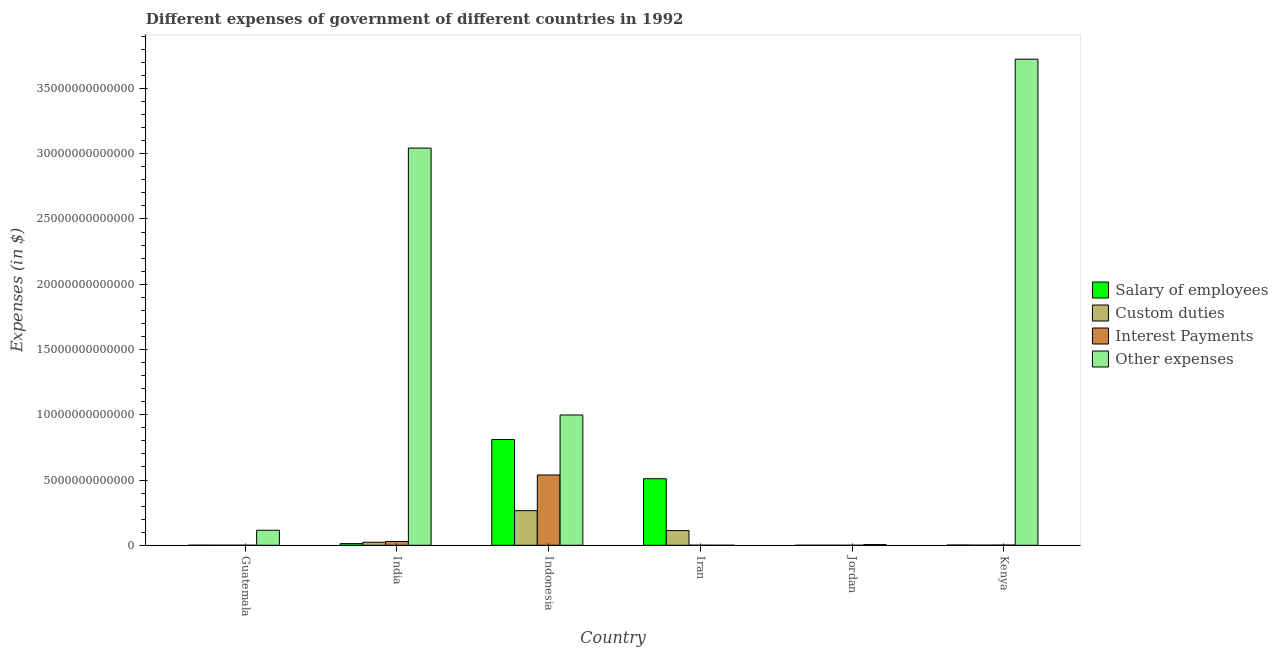Are the number of bars per tick equal to the number of legend labels?
Your answer should be very brief. Yes. How many bars are there on the 6th tick from the left?
Offer a very short reply. 4. What is the label of the 6th group of bars from the left?
Offer a terse response. Kenya. What is the amount spent on custom duties in Guatemala?
Keep it short and to the point. 1.15e+09. Across all countries, what is the maximum amount spent on custom duties?
Provide a succinct answer. 2.65e+12. Across all countries, what is the minimum amount spent on salary of employees?
Your response must be concise. 5.57e+08. In which country was the amount spent on other expenses maximum?
Your answer should be very brief. Kenya. In which country was the amount spent on salary of employees minimum?
Your answer should be very brief. Jordan. What is the total amount spent on salary of employees in the graph?
Give a very brief answer. 1.34e+13. What is the difference between the amount spent on salary of employees in India and that in Kenya?
Ensure brevity in your answer.  1.07e+11. What is the difference between the amount spent on interest payments in Iran and the amount spent on salary of employees in Jordan?
Keep it short and to the point. 2.44e+09. What is the average amount spent on salary of employees per country?
Your response must be concise. 2.23e+12. What is the difference between the amount spent on salary of employees and amount spent on other expenses in India?
Provide a succinct answer. -3.03e+13. In how many countries, is the amount spent on other expenses greater than 1000000000000 $?
Provide a short and direct response. 4. What is the ratio of the amount spent on custom duties in India to that in Kenya?
Provide a short and direct response. 30.07. Is the amount spent on custom duties in Indonesia less than that in Iran?
Provide a short and direct response. No. What is the difference between the highest and the second highest amount spent on interest payments?
Give a very brief answer. 5.10e+12. What is the difference between the highest and the lowest amount spent on custom duties?
Offer a terse response. 2.65e+12. Is the sum of the amount spent on salary of employees in India and Indonesia greater than the maximum amount spent on other expenses across all countries?
Your answer should be compact. No. Is it the case that in every country, the sum of the amount spent on interest payments and amount spent on other expenses is greater than the sum of amount spent on custom duties and amount spent on salary of employees?
Give a very brief answer. No. What does the 3rd bar from the left in Iran represents?
Keep it short and to the point. Interest Payments. What does the 2nd bar from the right in Indonesia represents?
Make the answer very short. Interest Payments. How many bars are there?
Provide a short and direct response. 24. Are all the bars in the graph horizontal?
Keep it short and to the point. No. What is the difference between two consecutive major ticks on the Y-axis?
Your response must be concise. 5.00e+12. Does the graph contain any zero values?
Provide a succinct answer. No. Does the graph contain grids?
Provide a short and direct response. No. Where does the legend appear in the graph?
Provide a short and direct response. Center right. How are the legend labels stacked?
Offer a very short reply. Vertical. What is the title of the graph?
Your answer should be very brief. Different expenses of government of different countries in 1992. What is the label or title of the X-axis?
Offer a very short reply. Country. What is the label or title of the Y-axis?
Provide a short and direct response. Expenses (in $). What is the Expenses (in $) of Salary of employees in Guatemala?
Your answer should be very brief. 1.87e+09. What is the Expenses (in $) in Custom duties in Guatemala?
Ensure brevity in your answer.  1.15e+09. What is the Expenses (in $) in Interest Payments in Guatemala?
Make the answer very short. 5.30e+08. What is the Expenses (in $) in Other expenses in Guatemala?
Make the answer very short. 1.15e+12. What is the Expenses (in $) of Salary of employees in India?
Make the answer very short. 1.26e+11. What is the Expenses (in $) of Custom duties in India?
Provide a short and direct response. 2.33e+11. What is the Expenses (in $) of Interest Payments in India?
Keep it short and to the point. 2.91e+11. What is the Expenses (in $) in Other expenses in India?
Your answer should be compact. 3.04e+13. What is the Expenses (in $) of Salary of employees in Indonesia?
Provide a succinct answer. 8.10e+12. What is the Expenses (in $) of Custom duties in Indonesia?
Offer a very short reply. 2.65e+12. What is the Expenses (in $) of Interest Payments in Indonesia?
Provide a succinct answer. 5.39e+12. What is the Expenses (in $) of Other expenses in Indonesia?
Keep it short and to the point. 9.98e+12. What is the Expenses (in $) of Salary of employees in Iran?
Your answer should be very brief. 5.10e+12. What is the Expenses (in $) of Custom duties in Iran?
Provide a short and direct response. 1.12e+12. What is the Expenses (in $) of Interest Payments in Iran?
Offer a very short reply. 3.00e+09. What is the Expenses (in $) in Other expenses in Iran?
Your answer should be compact. 8.91e+08. What is the Expenses (in $) in Salary of employees in Jordan?
Your answer should be compact. 5.57e+08. What is the Expenses (in $) of Custom duties in Jordan?
Offer a terse response. 3.89e+08. What is the Expenses (in $) of Interest Payments in Jordan?
Provide a succinct answer. 1.56e+08. What is the Expenses (in $) of Other expenses in Jordan?
Give a very brief answer. 5.39e+1. What is the Expenses (in $) of Salary of employees in Kenya?
Your answer should be very brief. 1.91e+1. What is the Expenses (in $) of Custom duties in Kenya?
Your response must be concise. 7.74e+09. What is the Expenses (in $) of Interest Payments in Kenya?
Give a very brief answer. 1.49e+1. What is the Expenses (in $) in Other expenses in Kenya?
Your answer should be very brief. 3.72e+13. Across all countries, what is the maximum Expenses (in $) of Salary of employees?
Offer a terse response. 8.10e+12. Across all countries, what is the maximum Expenses (in $) of Custom duties?
Your answer should be compact. 2.65e+12. Across all countries, what is the maximum Expenses (in $) of Interest Payments?
Make the answer very short. 5.39e+12. Across all countries, what is the maximum Expenses (in $) of Other expenses?
Make the answer very short. 3.72e+13. Across all countries, what is the minimum Expenses (in $) in Salary of employees?
Keep it short and to the point. 5.57e+08. Across all countries, what is the minimum Expenses (in $) in Custom duties?
Make the answer very short. 3.89e+08. Across all countries, what is the minimum Expenses (in $) of Interest Payments?
Make the answer very short. 1.56e+08. Across all countries, what is the minimum Expenses (in $) in Other expenses?
Your answer should be very brief. 8.91e+08. What is the total Expenses (in $) of Salary of employees in the graph?
Give a very brief answer. 1.34e+13. What is the total Expenses (in $) in Custom duties in the graph?
Your answer should be very brief. 4.02e+12. What is the total Expenses (in $) of Interest Payments in the graph?
Keep it short and to the point. 5.69e+12. What is the total Expenses (in $) in Other expenses in the graph?
Your response must be concise. 7.89e+13. What is the difference between the Expenses (in $) in Salary of employees in Guatemala and that in India?
Your answer should be compact. -1.24e+11. What is the difference between the Expenses (in $) in Custom duties in Guatemala and that in India?
Keep it short and to the point. -2.32e+11. What is the difference between the Expenses (in $) of Interest Payments in Guatemala and that in India?
Give a very brief answer. -2.90e+11. What is the difference between the Expenses (in $) of Other expenses in Guatemala and that in India?
Provide a succinct answer. -2.93e+13. What is the difference between the Expenses (in $) in Salary of employees in Guatemala and that in Indonesia?
Your answer should be compact. -8.10e+12. What is the difference between the Expenses (in $) of Custom duties in Guatemala and that in Indonesia?
Your answer should be very brief. -2.65e+12. What is the difference between the Expenses (in $) in Interest Payments in Guatemala and that in Indonesia?
Your answer should be very brief. -5.39e+12. What is the difference between the Expenses (in $) of Other expenses in Guatemala and that in Indonesia?
Offer a terse response. -8.83e+12. What is the difference between the Expenses (in $) in Salary of employees in Guatemala and that in Iran?
Your answer should be very brief. -5.10e+12. What is the difference between the Expenses (in $) of Custom duties in Guatemala and that in Iran?
Your response must be concise. -1.12e+12. What is the difference between the Expenses (in $) in Interest Payments in Guatemala and that in Iran?
Offer a terse response. -2.47e+09. What is the difference between the Expenses (in $) in Other expenses in Guatemala and that in Iran?
Give a very brief answer. 1.15e+12. What is the difference between the Expenses (in $) of Salary of employees in Guatemala and that in Jordan?
Provide a short and direct response. 1.32e+09. What is the difference between the Expenses (in $) in Custom duties in Guatemala and that in Jordan?
Give a very brief answer. 7.58e+08. What is the difference between the Expenses (in $) in Interest Payments in Guatemala and that in Jordan?
Provide a short and direct response. 3.74e+08. What is the difference between the Expenses (in $) of Other expenses in Guatemala and that in Jordan?
Offer a very short reply. 1.10e+12. What is the difference between the Expenses (in $) of Salary of employees in Guatemala and that in Kenya?
Your response must be concise. -1.72e+1. What is the difference between the Expenses (in $) of Custom duties in Guatemala and that in Kenya?
Your response must be concise. -6.59e+09. What is the difference between the Expenses (in $) of Interest Payments in Guatemala and that in Kenya?
Ensure brevity in your answer.  -1.44e+1. What is the difference between the Expenses (in $) in Other expenses in Guatemala and that in Kenya?
Ensure brevity in your answer.  -3.61e+13. What is the difference between the Expenses (in $) in Salary of employees in India and that in Indonesia?
Ensure brevity in your answer.  -7.98e+12. What is the difference between the Expenses (in $) in Custom duties in India and that in Indonesia?
Offer a terse response. -2.42e+12. What is the difference between the Expenses (in $) of Interest Payments in India and that in Indonesia?
Provide a short and direct response. -5.10e+12. What is the difference between the Expenses (in $) of Other expenses in India and that in Indonesia?
Your response must be concise. 2.04e+13. What is the difference between the Expenses (in $) in Salary of employees in India and that in Iran?
Your answer should be very brief. -4.97e+12. What is the difference between the Expenses (in $) in Custom duties in India and that in Iran?
Provide a short and direct response. -8.92e+11. What is the difference between the Expenses (in $) of Interest Payments in India and that in Iran?
Offer a very short reply. 2.88e+11. What is the difference between the Expenses (in $) in Other expenses in India and that in Iran?
Ensure brevity in your answer.  3.04e+13. What is the difference between the Expenses (in $) of Salary of employees in India and that in Jordan?
Your answer should be very brief. 1.26e+11. What is the difference between the Expenses (in $) of Custom duties in India and that in Jordan?
Your answer should be very brief. 2.32e+11. What is the difference between the Expenses (in $) in Interest Payments in India and that in Jordan?
Offer a terse response. 2.90e+11. What is the difference between the Expenses (in $) in Other expenses in India and that in Jordan?
Make the answer very short. 3.04e+13. What is the difference between the Expenses (in $) in Salary of employees in India and that in Kenya?
Provide a short and direct response. 1.07e+11. What is the difference between the Expenses (in $) of Custom duties in India and that in Kenya?
Your answer should be compact. 2.25e+11. What is the difference between the Expenses (in $) in Interest Payments in India and that in Kenya?
Provide a short and direct response. 2.76e+11. What is the difference between the Expenses (in $) in Other expenses in India and that in Kenya?
Provide a succinct answer. -6.81e+12. What is the difference between the Expenses (in $) in Salary of employees in Indonesia and that in Iran?
Your response must be concise. 3.00e+12. What is the difference between the Expenses (in $) in Custom duties in Indonesia and that in Iran?
Your answer should be very brief. 1.53e+12. What is the difference between the Expenses (in $) of Interest Payments in Indonesia and that in Iran?
Make the answer very short. 5.38e+12. What is the difference between the Expenses (in $) in Other expenses in Indonesia and that in Iran?
Your response must be concise. 9.98e+12. What is the difference between the Expenses (in $) of Salary of employees in Indonesia and that in Jordan?
Ensure brevity in your answer.  8.10e+12. What is the difference between the Expenses (in $) in Custom duties in Indonesia and that in Jordan?
Your answer should be very brief. 2.65e+12. What is the difference between the Expenses (in $) of Interest Payments in Indonesia and that in Jordan?
Keep it short and to the point. 5.39e+12. What is the difference between the Expenses (in $) of Other expenses in Indonesia and that in Jordan?
Provide a succinct answer. 9.93e+12. What is the difference between the Expenses (in $) of Salary of employees in Indonesia and that in Kenya?
Keep it short and to the point. 8.09e+12. What is the difference between the Expenses (in $) in Custom duties in Indonesia and that in Kenya?
Your answer should be compact. 2.64e+12. What is the difference between the Expenses (in $) of Interest Payments in Indonesia and that in Kenya?
Your answer should be very brief. 5.37e+12. What is the difference between the Expenses (in $) of Other expenses in Indonesia and that in Kenya?
Your response must be concise. -2.73e+13. What is the difference between the Expenses (in $) of Salary of employees in Iran and that in Jordan?
Offer a very short reply. 5.10e+12. What is the difference between the Expenses (in $) of Custom duties in Iran and that in Jordan?
Make the answer very short. 1.12e+12. What is the difference between the Expenses (in $) of Interest Payments in Iran and that in Jordan?
Offer a very short reply. 2.84e+09. What is the difference between the Expenses (in $) in Other expenses in Iran and that in Jordan?
Provide a short and direct response. -5.30e+1. What is the difference between the Expenses (in $) of Salary of employees in Iran and that in Kenya?
Offer a very short reply. 5.08e+12. What is the difference between the Expenses (in $) in Custom duties in Iran and that in Kenya?
Offer a terse response. 1.12e+12. What is the difference between the Expenses (in $) of Interest Payments in Iran and that in Kenya?
Offer a very short reply. -1.19e+1. What is the difference between the Expenses (in $) of Other expenses in Iran and that in Kenya?
Offer a very short reply. -3.72e+13. What is the difference between the Expenses (in $) in Salary of employees in Jordan and that in Kenya?
Your answer should be compact. -1.86e+1. What is the difference between the Expenses (in $) of Custom duties in Jordan and that in Kenya?
Your response must be concise. -7.35e+09. What is the difference between the Expenses (in $) of Interest Payments in Jordan and that in Kenya?
Make the answer very short. -1.48e+1. What is the difference between the Expenses (in $) of Other expenses in Jordan and that in Kenya?
Make the answer very short. -3.72e+13. What is the difference between the Expenses (in $) of Salary of employees in Guatemala and the Expenses (in $) of Custom duties in India?
Provide a short and direct response. -2.31e+11. What is the difference between the Expenses (in $) in Salary of employees in Guatemala and the Expenses (in $) in Interest Payments in India?
Ensure brevity in your answer.  -2.89e+11. What is the difference between the Expenses (in $) of Salary of employees in Guatemala and the Expenses (in $) of Other expenses in India?
Ensure brevity in your answer.  -3.04e+13. What is the difference between the Expenses (in $) of Custom duties in Guatemala and the Expenses (in $) of Interest Payments in India?
Provide a short and direct response. -2.89e+11. What is the difference between the Expenses (in $) of Custom duties in Guatemala and the Expenses (in $) of Other expenses in India?
Your answer should be compact. -3.04e+13. What is the difference between the Expenses (in $) of Interest Payments in Guatemala and the Expenses (in $) of Other expenses in India?
Your answer should be very brief. -3.04e+13. What is the difference between the Expenses (in $) of Salary of employees in Guatemala and the Expenses (in $) of Custom duties in Indonesia?
Give a very brief answer. -2.65e+12. What is the difference between the Expenses (in $) of Salary of employees in Guatemala and the Expenses (in $) of Interest Payments in Indonesia?
Offer a terse response. -5.38e+12. What is the difference between the Expenses (in $) of Salary of employees in Guatemala and the Expenses (in $) of Other expenses in Indonesia?
Ensure brevity in your answer.  -9.98e+12. What is the difference between the Expenses (in $) of Custom duties in Guatemala and the Expenses (in $) of Interest Payments in Indonesia?
Give a very brief answer. -5.38e+12. What is the difference between the Expenses (in $) of Custom duties in Guatemala and the Expenses (in $) of Other expenses in Indonesia?
Offer a very short reply. -9.98e+12. What is the difference between the Expenses (in $) of Interest Payments in Guatemala and the Expenses (in $) of Other expenses in Indonesia?
Ensure brevity in your answer.  -9.98e+12. What is the difference between the Expenses (in $) of Salary of employees in Guatemala and the Expenses (in $) of Custom duties in Iran?
Offer a terse response. -1.12e+12. What is the difference between the Expenses (in $) of Salary of employees in Guatemala and the Expenses (in $) of Interest Payments in Iran?
Keep it short and to the point. -1.13e+09. What is the difference between the Expenses (in $) in Salary of employees in Guatemala and the Expenses (in $) in Other expenses in Iran?
Ensure brevity in your answer.  9.83e+08. What is the difference between the Expenses (in $) in Custom duties in Guatemala and the Expenses (in $) in Interest Payments in Iran?
Offer a terse response. -1.85e+09. What is the difference between the Expenses (in $) of Custom duties in Guatemala and the Expenses (in $) of Other expenses in Iran?
Ensure brevity in your answer.  2.56e+08. What is the difference between the Expenses (in $) of Interest Payments in Guatemala and the Expenses (in $) of Other expenses in Iran?
Your answer should be compact. -3.61e+08. What is the difference between the Expenses (in $) in Salary of employees in Guatemala and the Expenses (in $) in Custom duties in Jordan?
Keep it short and to the point. 1.49e+09. What is the difference between the Expenses (in $) of Salary of employees in Guatemala and the Expenses (in $) of Interest Payments in Jordan?
Make the answer very short. 1.72e+09. What is the difference between the Expenses (in $) of Salary of employees in Guatemala and the Expenses (in $) of Other expenses in Jordan?
Offer a very short reply. -5.20e+1. What is the difference between the Expenses (in $) of Custom duties in Guatemala and the Expenses (in $) of Interest Payments in Jordan?
Your answer should be very brief. 9.92e+08. What is the difference between the Expenses (in $) in Custom duties in Guatemala and the Expenses (in $) in Other expenses in Jordan?
Offer a very short reply. -5.28e+1. What is the difference between the Expenses (in $) in Interest Payments in Guatemala and the Expenses (in $) in Other expenses in Jordan?
Offer a terse response. -5.34e+1. What is the difference between the Expenses (in $) in Salary of employees in Guatemala and the Expenses (in $) in Custom duties in Kenya?
Your answer should be very brief. -5.86e+09. What is the difference between the Expenses (in $) of Salary of employees in Guatemala and the Expenses (in $) of Interest Payments in Kenya?
Ensure brevity in your answer.  -1.30e+1. What is the difference between the Expenses (in $) in Salary of employees in Guatemala and the Expenses (in $) in Other expenses in Kenya?
Provide a short and direct response. -3.72e+13. What is the difference between the Expenses (in $) in Custom duties in Guatemala and the Expenses (in $) in Interest Payments in Kenya?
Provide a succinct answer. -1.38e+1. What is the difference between the Expenses (in $) in Custom duties in Guatemala and the Expenses (in $) in Other expenses in Kenya?
Offer a very short reply. -3.72e+13. What is the difference between the Expenses (in $) in Interest Payments in Guatemala and the Expenses (in $) in Other expenses in Kenya?
Your response must be concise. -3.72e+13. What is the difference between the Expenses (in $) of Salary of employees in India and the Expenses (in $) of Custom duties in Indonesia?
Provide a short and direct response. -2.53e+12. What is the difference between the Expenses (in $) in Salary of employees in India and the Expenses (in $) in Interest Payments in Indonesia?
Provide a succinct answer. -5.26e+12. What is the difference between the Expenses (in $) of Salary of employees in India and the Expenses (in $) of Other expenses in Indonesia?
Keep it short and to the point. -9.86e+12. What is the difference between the Expenses (in $) in Custom duties in India and the Expenses (in $) in Interest Payments in Indonesia?
Offer a terse response. -5.15e+12. What is the difference between the Expenses (in $) in Custom duties in India and the Expenses (in $) in Other expenses in Indonesia?
Provide a succinct answer. -9.75e+12. What is the difference between the Expenses (in $) of Interest Payments in India and the Expenses (in $) of Other expenses in Indonesia?
Offer a very short reply. -9.69e+12. What is the difference between the Expenses (in $) in Salary of employees in India and the Expenses (in $) in Custom duties in Iran?
Ensure brevity in your answer.  -9.98e+11. What is the difference between the Expenses (in $) in Salary of employees in India and the Expenses (in $) in Interest Payments in Iran?
Provide a succinct answer. 1.23e+11. What is the difference between the Expenses (in $) of Salary of employees in India and the Expenses (in $) of Other expenses in Iran?
Provide a short and direct response. 1.25e+11. What is the difference between the Expenses (in $) in Custom duties in India and the Expenses (in $) in Interest Payments in Iran?
Offer a terse response. 2.30e+11. What is the difference between the Expenses (in $) in Custom duties in India and the Expenses (in $) in Other expenses in Iran?
Ensure brevity in your answer.  2.32e+11. What is the difference between the Expenses (in $) of Interest Payments in India and the Expenses (in $) of Other expenses in Iran?
Your response must be concise. 2.90e+11. What is the difference between the Expenses (in $) in Salary of employees in India and the Expenses (in $) in Custom duties in Jordan?
Your answer should be very brief. 1.26e+11. What is the difference between the Expenses (in $) in Salary of employees in India and the Expenses (in $) in Interest Payments in Jordan?
Ensure brevity in your answer.  1.26e+11. What is the difference between the Expenses (in $) in Salary of employees in India and the Expenses (in $) in Other expenses in Jordan?
Your answer should be very brief. 7.23e+1. What is the difference between the Expenses (in $) in Custom duties in India and the Expenses (in $) in Interest Payments in Jordan?
Your answer should be compact. 2.33e+11. What is the difference between the Expenses (in $) in Custom duties in India and the Expenses (in $) in Other expenses in Jordan?
Your response must be concise. 1.79e+11. What is the difference between the Expenses (in $) of Interest Payments in India and the Expenses (in $) of Other expenses in Jordan?
Your response must be concise. 2.37e+11. What is the difference between the Expenses (in $) in Salary of employees in India and the Expenses (in $) in Custom duties in Kenya?
Give a very brief answer. 1.19e+11. What is the difference between the Expenses (in $) in Salary of employees in India and the Expenses (in $) in Interest Payments in Kenya?
Ensure brevity in your answer.  1.11e+11. What is the difference between the Expenses (in $) of Salary of employees in India and the Expenses (in $) of Other expenses in Kenya?
Keep it short and to the point. -3.71e+13. What is the difference between the Expenses (in $) of Custom duties in India and the Expenses (in $) of Interest Payments in Kenya?
Offer a terse response. 2.18e+11. What is the difference between the Expenses (in $) in Custom duties in India and the Expenses (in $) in Other expenses in Kenya?
Offer a terse response. -3.70e+13. What is the difference between the Expenses (in $) of Interest Payments in India and the Expenses (in $) of Other expenses in Kenya?
Provide a succinct answer. -3.70e+13. What is the difference between the Expenses (in $) in Salary of employees in Indonesia and the Expenses (in $) in Custom duties in Iran?
Make the answer very short. 6.98e+12. What is the difference between the Expenses (in $) in Salary of employees in Indonesia and the Expenses (in $) in Interest Payments in Iran?
Make the answer very short. 8.10e+12. What is the difference between the Expenses (in $) in Salary of employees in Indonesia and the Expenses (in $) in Other expenses in Iran?
Offer a terse response. 8.10e+12. What is the difference between the Expenses (in $) in Custom duties in Indonesia and the Expenses (in $) in Interest Payments in Iran?
Your response must be concise. 2.65e+12. What is the difference between the Expenses (in $) of Custom duties in Indonesia and the Expenses (in $) of Other expenses in Iran?
Provide a short and direct response. 2.65e+12. What is the difference between the Expenses (in $) of Interest Payments in Indonesia and the Expenses (in $) of Other expenses in Iran?
Keep it short and to the point. 5.38e+12. What is the difference between the Expenses (in $) of Salary of employees in Indonesia and the Expenses (in $) of Custom duties in Jordan?
Provide a short and direct response. 8.10e+12. What is the difference between the Expenses (in $) of Salary of employees in Indonesia and the Expenses (in $) of Interest Payments in Jordan?
Offer a terse response. 8.10e+12. What is the difference between the Expenses (in $) in Salary of employees in Indonesia and the Expenses (in $) in Other expenses in Jordan?
Your answer should be very brief. 8.05e+12. What is the difference between the Expenses (in $) in Custom duties in Indonesia and the Expenses (in $) in Interest Payments in Jordan?
Provide a succinct answer. 2.65e+12. What is the difference between the Expenses (in $) of Custom duties in Indonesia and the Expenses (in $) of Other expenses in Jordan?
Keep it short and to the point. 2.60e+12. What is the difference between the Expenses (in $) of Interest Payments in Indonesia and the Expenses (in $) of Other expenses in Jordan?
Keep it short and to the point. 5.33e+12. What is the difference between the Expenses (in $) of Salary of employees in Indonesia and the Expenses (in $) of Custom duties in Kenya?
Your answer should be very brief. 8.10e+12. What is the difference between the Expenses (in $) in Salary of employees in Indonesia and the Expenses (in $) in Interest Payments in Kenya?
Give a very brief answer. 8.09e+12. What is the difference between the Expenses (in $) of Salary of employees in Indonesia and the Expenses (in $) of Other expenses in Kenya?
Your answer should be very brief. -2.91e+13. What is the difference between the Expenses (in $) in Custom duties in Indonesia and the Expenses (in $) in Interest Payments in Kenya?
Offer a terse response. 2.64e+12. What is the difference between the Expenses (in $) in Custom duties in Indonesia and the Expenses (in $) in Other expenses in Kenya?
Ensure brevity in your answer.  -3.46e+13. What is the difference between the Expenses (in $) of Interest Payments in Indonesia and the Expenses (in $) of Other expenses in Kenya?
Give a very brief answer. -3.19e+13. What is the difference between the Expenses (in $) of Salary of employees in Iran and the Expenses (in $) of Custom duties in Jordan?
Your response must be concise. 5.10e+12. What is the difference between the Expenses (in $) in Salary of employees in Iran and the Expenses (in $) in Interest Payments in Jordan?
Keep it short and to the point. 5.10e+12. What is the difference between the Expenses (in $) in Salary of employees in Iran and the Expenses (in $) in Other expenses in Jordan?
Keep it short and to the point. 5.05e+12. What is the difference between the Expenses (in $) of Custom duties in Iran and the Expenses (in $) of Interest Payments in Jordan?
Your answer should be very brief. 1.12e+12. What is the difference between the Expenses (in $) of Custom duties in Iran and the Expenses (in $) of Other expenses in Jordan?
Offer a terse response. 1.07e+12. What is the difference between the Expenses (in $) of Interest Payments in Iran and the Expenses (in $) of Other expenses in Jordan?
Offer a terse response. -5.09e+1. What is the difference between the Expenses (in $) of Salary of employees in Iran and the Expenses (in $) of Custom duties in Kenya?
Your answer should be very brief. 5.09e+12. What is the difference between the Expenses (in $) in Salary of employees in Iran and the Expenses (in $) in Interest Payments in Kenya?
Your answer should be very brief. 5.09e+12. What is the difference between the Expenses (in $) in Salary of employees in Iran and the Expenses (in $) in Other expenses in Kenya?
Provide a short and direct response. -3.21e+13. What is the difference between the Expenses (in $) in Custom duties in Iran and the Expenses (in $) in Interest Payments in Kenya?
Your answer should be very brief. 1.11e+12. What is the difference between the Expenses (in $) in Custom duties in Iran and the Expenses (in $) in Other expenses in Kenya?
Give a very brief answer. -3.61e+13. What is the difference between the Expenses (in $) in Interest Payments in Iran and the Expenses (in $) in Other expenses in Kenya?
Provide a succinct answer. -3.72e+13. What is the difference between the Expenses (in $) in Salary of employees in Jordan and the Expenses (in $) in Custom duties in Kenya?
Your answer should be very brief. -7.18e+09. What is the difference between the Expenses (in $) of Salary of employees in Jordan and the Expenses (in $) of Interest Payments in Kenya?
Your answer should be very brief. -1.44e+1. What is the difference between the Expenses (in $) in Salary of employees in Jordan and the Expenses (in $) in Other expenses in Kenya?
Ensure brevity in your answer.  -3.72e+13. What is the difference between the Expenses (in $) in Custom duties in Jordan and the Expenses (in $) in Interest Payments in Kenya?
Keep it short and to the point. -1.45e+1. What is the difference between the Expenses (in $) of Custom duties in Jordan and the Expenses (in $) of Other expenses in Kenya?
Provide a short and direct response. -3.72e+13. What is the difference between the Expenses (in $) of Interest Payments in Jordan and the Expenses (in $) of Other expenses in Kenya?
Make the answer very short. -3.72e+13. What is the average Expenses (in $) of Salary of employees per country?
Keep it short and to the point. 2.23e+12. What is the average Expenses (in $) in Custom duties per country?
Provide a succinct answer. 6.70e+11. What is the average Expenses (in $) in Interest Payments per country?
Offer a terse response. 9.49e+11. What is the average Expenses (in $) of Other expenses per country?
Offer a terse response. 1.31e+13. What is the difference between the Expenses (in $) in Salary of employees and Expenses (in $) in Custom duties in Guatemala?
Offer a terse response. 7.27e+08. What is the difference between the Expenses (in $) of Salary of employees and Expenses (in $) of Interest Payments in Guatemala?
Your answer should be very brief. 1.34e+09. What is the difference between the Expenses (in $) of Salary of employees and Expenses (in $) of Other expenses in Guatemala?
Your response must be concise. -1.15e+12. What is the difference between the Expenses (in $) in Custom duties and Expenses (in $) in Interest Payments in Guatemala?
Your response must be concise. 6.17e+08. What is the difference between the Expenses (in $) of Custom duties and Expenses (in $) of Other expenses in Guatemala?
Ensure brevity in your answer.  -1.15e+12. What is the difference between the Expenses (in $) in Interest Payments and Expenses (in $) in Other expenses in Guatemala?
Ensure brevity in your answer.  -1.15e+12. What is the difference between the Expenses (in $) of Salary of employees and Expenses (in $) of Custom duties in India?
Your answer should be very brief. -1.06e+11. What is the difference between the Expenses (in $) of Salary of employees and Expenses (in $) of Interest Payments in India?
Ensure brevity in your answer.  -1.64e+11. What is the difference between the Expenses (in $) in Salary of employees and Expenses (in $) in Other expenses in India?
Provide a succinct answer. -3.03e+13. What is the difference between the Expenses (in $) of Custom duties and Expenses (in $) of Interest Payments in India?
Make the answer very short. -5.79e+1. What is the difference between the Expenses (in $) of Custom duties and Expenses (in $) of Other expenses in India?
Give a very brief answer. -3.02e+13. What is the difference between the Expenses (in $) of Interest Payments and Expenses (in $) of Other expenses in India?
Offer a very short reply. -3.01e+13. What is the difference between the Expenses (in $) of Salary of employees and Expenses (in $) of Custom duties in Indonesia?
Your answer should be very brief. 5.45e+12. What is the difference between the Expenses (in $) in Salary of employees and Expenses (in $) in Interest Payments in Indonesia?
Offer a terse response. 2.72e+12. What is the difference between the Expenses (in $) in Salary of employees and Expenses (in $) in Other expenses in Indonesia?
Give a very brief answer. -1.88e+12. What is the difference between the Expenses (in $) in Custom duties and Expenses (in $) in Interest Payments in Indonesia?
Your answer should be very brief. -2.73e+12. What is the difference between the Expenses (in $) of Custom duties and Expenses (in $) of Other expenses in Indonesia?
Give a very brief answer. -7.33e+12. What is the difference between the Expenses (in $) of Interest Payments and Expenses (in $) of Other expenses in Indonesia?
Your response must be concise. -4.60e+12. What is the difference between the Expenses (in $) in Salary of employees and Expenses (in $) in Custom duties in Iran?
Keep it short and to the point. 3.98e+12. What is the difference between the Expenses (in $) of Salary of employees and Expenses (in $) of Interest Payments in Iran?
Ensure brevity in your answer.  5.10e+12. What is the difference between the Expenses (in $) of Salary of employees and Expenses (in $) of Other expenses in Iran?
Offer a terse response. 5.10e+12. What is the difference between the Expenses (in $) of Custom duties and Expenses (in $) of Interest Payments in Iran?
Provide a succinct answer. 1.12e+12. What is the difference between the Expenses (in $) of Custom duties and Expenses (in $) of Other expenses in Iran?
Your answer should be compact. 1.12e+12. What is the difference between the Expenses (in $) of Interest Payments and Expenses (in $) of Other expenses in Iran?
Make the answer very short. 2.11e+09. What is the difference between the Expenses (in $) of Salary of employees and Expenses (in $) of Custom duties in Jordan?
Your answer should be very brief. 1.68e+08. What is the difference between the Expenses (in $) of Salary of employees and Expenses (in $) of Interest Payments in Jordan?
Offer a very short reply. 4.01e+08. What is the difference between the Expenses (in $) in Salary of employees and Expenses (in $) in Other expenses in Jordan?
Provide a succinct answer. -5.34e+1. What is the difference between the Expenses (in $) of Custom duties and Expenses (in $) of Interest Payments in Jordan?
Offer a terse response. 2.34e+08. What is the difference between the Expenses (in $) of Custom duties and Expenses (in $) of Other expenses in Jordan?
Ensure brevity in your answer.  -5.35e+1. What is the difference between the Expenses (in $) in Interest Payments and Expenses (in $) in Other expenses in Jordan?
Offer a terse response. -5.38e+1. What is the difference between the Expenses (in $) in Salary of employees and Expenses (in $) in Custom duties in Kenya?
Ensure brevity in your answer.  1.14e+1. What is the difference between the Expenses (in $) in Salary of employees and Expenses (in $) in Interest Payments in Kenya?
Your answer should be very brief. 4.20e+09. What is the difference between the Expenses (in $) in Salary of employees and Expenses (in $) in Other expenses in Kenya?
Offer a terse response. -3.72e+13. What is the difference between the Expenses (in $) of Custom duties and Expenses (in $) of Interest Payments in Kenya?
Offer a very short reply. -7.18e+09. What is the difference between the Expenses (in $) of Custom duties and Expenses (in $) of Other expenses in Kenya?
Offer a terse response. -3.72e+13. What is the difference between the Expenses (in $) of Interest Payments and Expenses (in $) of Other expenses in Kenya?
Ensure brevity in your answer.  -3.72e+13. What is the ratio of the Expenses (in $) of Salary of employees in Guatemala to that in India?
Give a very brief answer. 0.01. What is the ratio of the Expenses (in $) of Custom duties in Guatemala to that in India?
Offer a terse response. 0. What is the ratio of the Expenses (in $) in Interest Payments in Guatemala to that in India?
Keep it short and to the point. 0. What is the ratio of the Expenses (in $) of Other expenses in Guatemala to that in India?
Your response must be concise. 0.04. What is the ratio of the Expenses (in $) in Salary of employees in Guatemala to that in Indonesia?
Provide a short and direct response. 0. What is the ratio of the Expenses (in $) of Custom duties in Guatemala to that in Indonesia?
Your answer should be compact. 0. What is the ratio of the Expenses (in $) of Other expenses in Guatemala to that in Indonesia?
Ensure brevity in your answer.  0.12. What is the ratio of the Expenses (in $) in Interest Payments in Guatemala to that in Iran?
Your answer should be very brief. 0.18. What is the ratio of the Expenses (in $) in Other expenses in Guatemala to that in Iran?
Offer a very short reply. 1291.06. What is the ratio of the Expenses (in $) in Salary of employees in Guatemala to that in Jordan?
Offer a very short reply. 3.36. What is the ratio of the Expenses (in $) of Custom duties in Guatemala to that in Jordan?
Your response must be concise. 2.95. What is the ratio of the Expenses (in $) in Interest Payments in Guatemala to that in Jordan?
Ensure brevity in your answer.  3.4. What is the ratio of the Expenses (in $) of Other expenses in Guatemala to that in Jordan?
Offer a terse response. 21.34. What is the ratio of the Expenses (in $) of Salary of employees in Guatemala to that in Kenya?
Give a very brief answer. 0.1. What is the ratio of the Expenses (in $) of Custom duties in Guatemala to that in Kenya?
Your answer should be very brief. 0.15. What is the ratio of the Expenses (in $) in Interest Payments in Guatemala to that in Kenya?
Provide a short and direct response. 0.04. What is the ratio of the Expenses (in $) in Other expenses in Guatemala to that in Kenya?
Your answer should be very brief. 0.03. What is the ratio of the Expenses (in $) of Salary of employees in India to that in Indonesia?
Provide a succinct answer. 0.02. What is the ratio of the Expenses (in $) in Custom duties in India to that in Indonesia?
Your response must be concise. 0.09. What is the ratio of the Expenses (in $) in Interest Payments in India to that in Indonesia?
Ensure brevity in your answer.  0.05. What is the ratio of the Expenses (in $) of Other expenses in India to that in Indonesia?
Give a very brief answer. 3.05. What is the ratio of the Expenses (in $) of Salary of employees in India to that in Iran?
Your response must be concise. 0.02. What is the ratio of the Expenses (in $) in Custom duties in India to that in Iran?
Your answer should be very brief. 0.21. What is the ratio of the Expenses (in $) of Interest Payments in India to that in Iran?
Your response must be concise. 96.85. What is the ratio of the Expenses (in $) of Other expenses in India to that in Iran?
Your response must be concise. 3.41e+04. What is the ratio of the Expenses (in $) of Salary of employees in India to that in Jordan?
Your response must be concise. 226.57. What is the ratio of the Expenses (in $) in Custom duties in India to that in Jordan?
Ensure brevity in your answer.  597.73. What is the ratio of the Expenses (in $) in Interest Payments in India to that in Jordan?
Give a very brief answer. 1865.13. What is the ratio of the Expenses (in $) of Other expenses in India to that in Jordan?
Offer a terse response. 564.49. What is the ratio of the Expenses (in $) in Salary of employees in India to that in Kenya?
Offer a terse response. 6.6. What is the ratio of the Expenses (in $) in Custom duties in India to that in Kenya?
Provide a short and direct response. 30.07. What is the ratio of the Expenses (in $) in Interest Payments in India to that in Kenya?
Give a very brief answer. 19.47. What is the ratio of the Expenses (in $) in Other expenses in India to that in Kenya?
Your answer should be compact. 0.82. What is the ratio of the Expenses (in $) of Salary of employees in Indonesia to that in Iran?
Ensure brevity in your answer.  1.59. What is the ratio of the Expenses (in $) in Custom duties in Indonesia to that in Iran?
Ensure brevity in your answer.  2.36. What is the ratio of the Expenses (in $) of Interest Payments in Indonesia to that in Iran?
Your response must be concise. 1795.23. What is the ratio of the Expenses (in $) of Other expenses in Indonesia to that in Iran?
Ensure brevity in your answer.  1.12e+04. What is the ratio of the Expenses (in $) in Salary of employees in Indonesia to that in Jordan?
Provide a short and direct response. 1.45e+04. What is the ratio of the Expenses (in $) in Custom duties in Indonesia to that in Jordan?
Make the answer very short. 6812.92. What is the ratio of the Expenses (in $) of Interest Payments in Indonesia to that in Jordan?
Your answer should be very brief. 3.46e+04. What is the ratio of the Expenses (in $) of Other expenses in Indonesia to that in Jordan?
Ensure brevity in your answer.  185.17. What is the ratio of the Expenses (in $) in Salary of employees in Indonesia to that in Kenya?
Keep it short and to the point. 423.94. What is the ratio of the Expenses (in $) in Custom duties in Indonesia to that in Kenya?
Your answer should be compact. 342.75. What is the ratio of the Expenses (in $) of Interest Payments in Indonesia to that in Kenya?
Your answer should be compact. 360.92. What is the ratio of the Expenses (in $) in Other expenses in Indonesia to that in Kenya?
Your answer should be compact. 0.27. What is the ratio of the Expenses (in $) in Salary of employees in Iran to that in Jordan?
Make the answer very short. 9154.87. What is the ratio of the Expenses (in $) in Custom duties in Iran to that in Jordan?
Offer a very short reply. 2888.59. What is the ratio of the Expenses (in $) in Interest Payments in Iran to that in Jordan?
Provide a short and direct response. 19.26. What is the ratio of the Expenses (in $) in Other expenses in Iran to that in Jordan?
Your answer should be compact. 0.02. What is the ratio of the Expenses (in $) of Salary of employees in Iran to that in Kenya?
Offer a terse response. 266.83. What is the ratio of the Expenses (in $) in Custom duties in Iran to that in Kenya?
Keep it short and to the point. 145.32. What is the ratio of the Expenses (in $) in Interest Payments in Iran to that in Kenya?
Ensure brevity in your answer.  0.2. What is the ratio of the Expenses (in $) in Salary of employees in Jordan to that in Kenya?
Give a very brief answer. 0.03. What is the ratio of the Expenses (in $) of Custom duties in Jordan to that in Kenya?
Your response must be concise. 0.05. What is the ratio of the Expenses (in $) in Interest Payments in Jordan to that in Kenya?
Offer a very short reply. 0.01. What is the ratio of the Expenses (in $) of Other expenses in Jordan to that in Kenya?
Give a very brief answer. 0. What is the difference between the highest and the second highest Expenses (in $) of Salary of employees?
Provide a succinct answer. 3.00e+12. What is the difference between the highest and the second highest Expenses (in $) of Custom duties?
Keep it short and to the point. 1.53e+12. What is the difference between the highest and the second highest Expenses (in $) in Interest Payments?
Your answer should be compact. 5.10e+12. What is the difference between the highest and the second highest Expenses (in $) in Other expenses?
Provide a short and direct response. 6.81e+12. What is the difference between the highest and the lowest Expenses (in $) of Salary of employees?
Provide a succinct answer. 8.10e+12. What is the difference between the highest and the lowest Expenses (in $) of Custom duties?
Keep it short and to the point. 2.65e+12. What is the difference between the highest and the lowest Expenses (in $) of Interest Payments?
Provide a succinct answer. 5.39e+12. What is the difference between the highest and the lowest Expenses (in $) in Other expenses?
Offer a very short reply. 3.72e+13. 